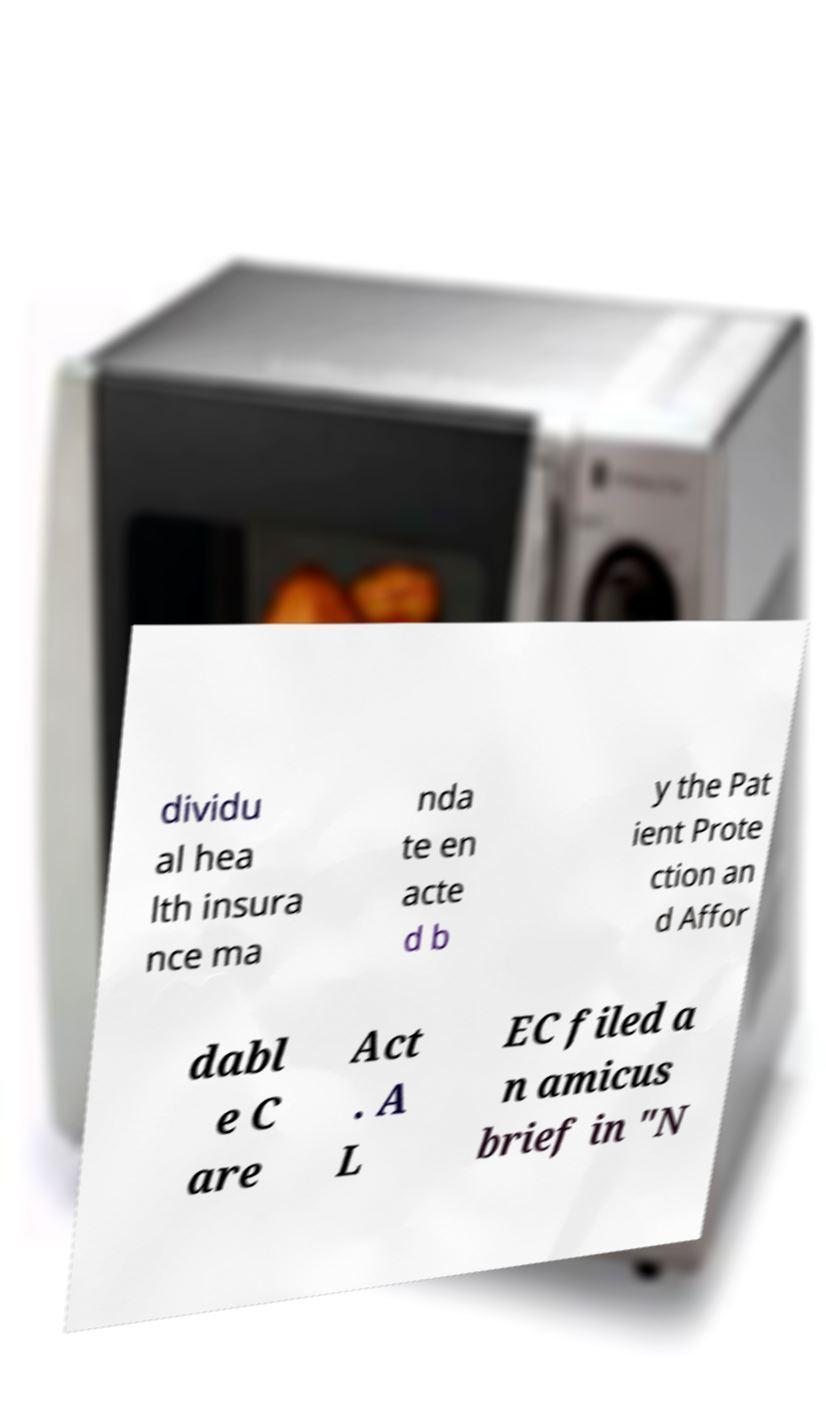Can you read and provide the text displayed in the image?This photo seems to have some interesting text. Can you extract and type it out for me? dividu al hea lth insura nce ma nda te en acte d b y the Pat ient Prote ction an d Affor dabl e C are Act . A L EC filed a n amicus brief in "N 